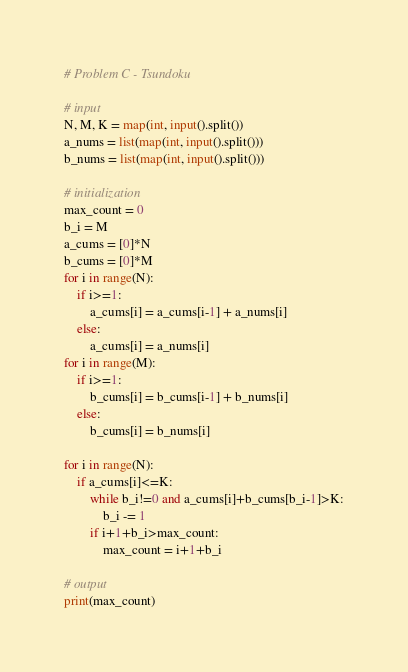Convert code to text. <code><loc_0><loc_0><loc_500><loc_500><_Python_># Problem C - Tsundoku

# input
N, M, K = map(int, input().split())
a_nums = list(map(int, input().split()))
b_nums = list(map(int, input().split()))

# initialization
max_count = 0
b_i = M
a_cums = [0]*N
b_cums = [0]*M
for i in range(N):
    if i>=1:
        a_cums[i] = a_cums[i-1] + a_nums[i]
    else:
        a_cums[i] = a_nums[i]
for i in range(M):
    if i>=1:
        b_cums[i] = b_cums[i-1] + b_nums[i]
    else:
        b_cums[i] = b_nums[i]

for i in range(N):
    if a_cums[i]<=K:
        while b_i!=0 and a_cums[i]+b_cums[b_i-1]>K:
            b_i -= 1
        if i+1+b_i>max_count:
            max_count = i+1+b_i

# output
print(max_count)
</code> 